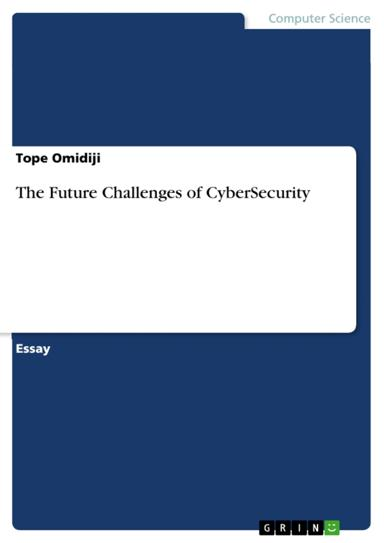What audience do you believe the author is targeting with this essay? Since cybersecurity is a concern that spans across various sectors, the target audience for "The Future Challenges of CyberSecurity" could include IT professionals, policy makers, business executives, and students in the field of Computer Science. The essay's content may be insightful for anyone vested in protecting digital infrastructure and sensitive information from cyber threats. 